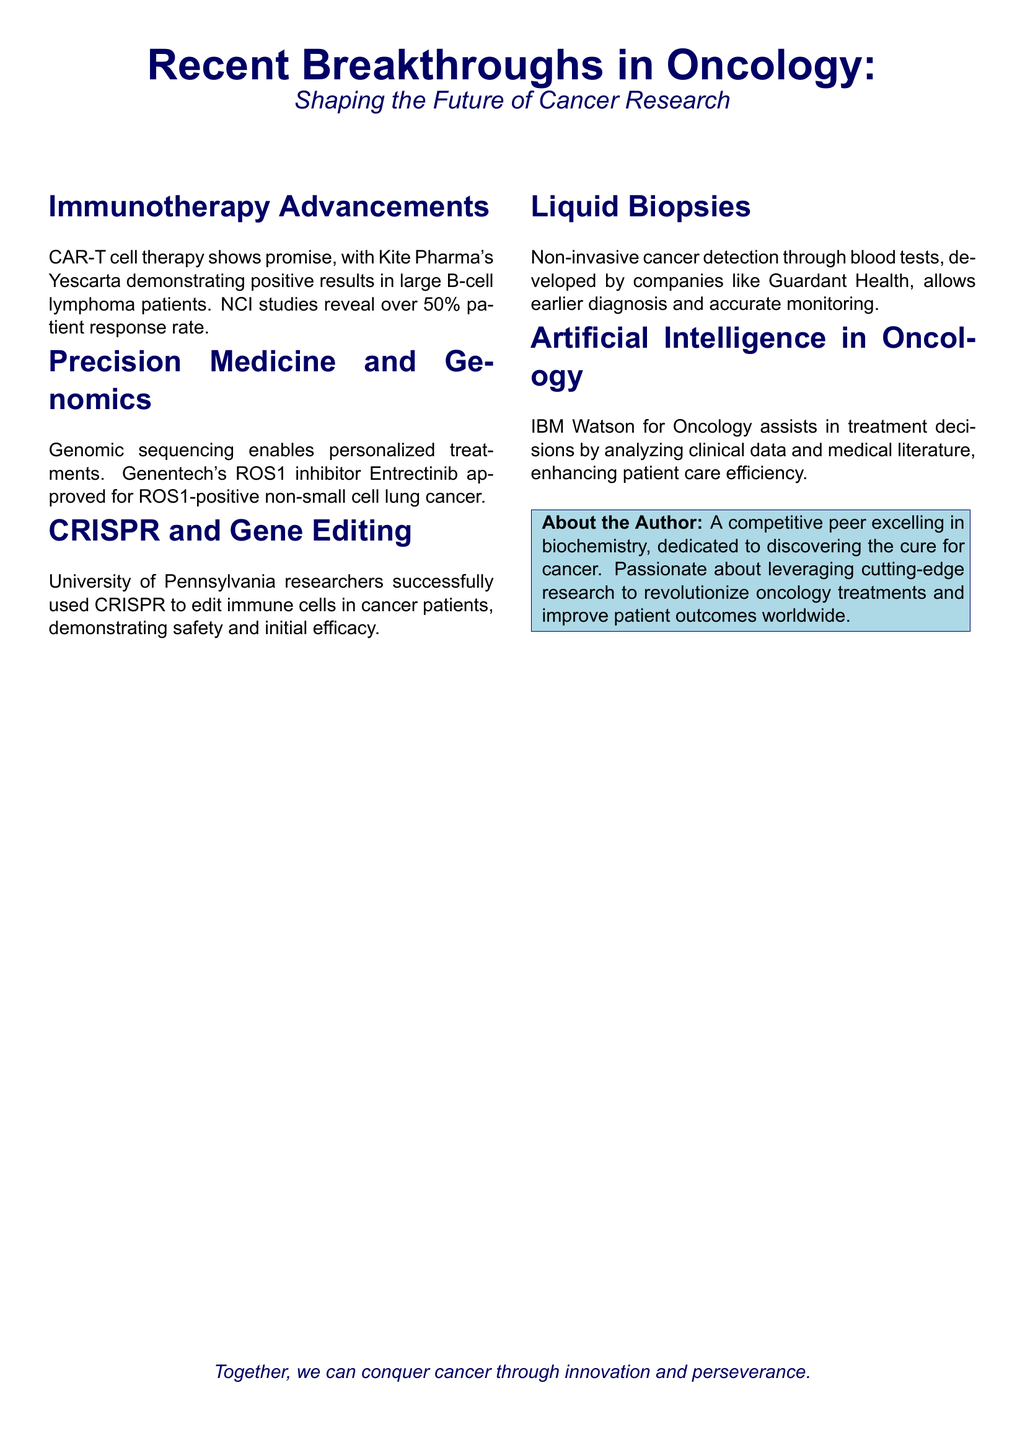What therapy shows promise in large B-cell lymphoma patients? The document states that CAR-T cell therapy shows promise, with Kite Pharma's Yescarta demonstrating positive results.
Answer: CAR-T cell therapy What is the patient response rate for Kite Pharma's Yescarta? According to the document, NCI studies reveal over 50% patient response rate.
Answer: Over 50% Which genomic sequencing product was approved for non-small cell lung cancer? The document mentions Genentech's ROS1 inhibitor Entrectinib was approved for ROS1-positive non-small cell lung cancer.
Answer: Entrectinib What technology did University of Pennsylvania researchers use for gene editing? The document indicates that researchers successfully used CRISPR to edit immune cells in cancer patients.
Answer: CRISPR What type of cancer detection is mentioned in the document? The document describes non-invasive cancer detection through blood tests as liquid biopsies.
Answer: Liquid biopsies Which company developed a non-invasive cancer detection method? The document states that Guardant Health developed non-invasive cancer detection through blood tests.
Answer: Guardant Health What role does IBM Watson for Oncology play in cancer treatment? The document explains that IBM Watson for Oncology assists in treatment decisions by analyzing clinical data and medical literature.
Answer: Assists in treatment decisions What is the author passionate about? The document indicates that the author is passionate about leveraging cutting-edge research to revolutionize oncology treatments.
Answer: Leveraging cutting-edge research How does the Playbill suggest we can conquer cancer? The closing statement suggests that together, we can conquer cancer through innovation and perseverance.
Answer: Innovation and perseverance 